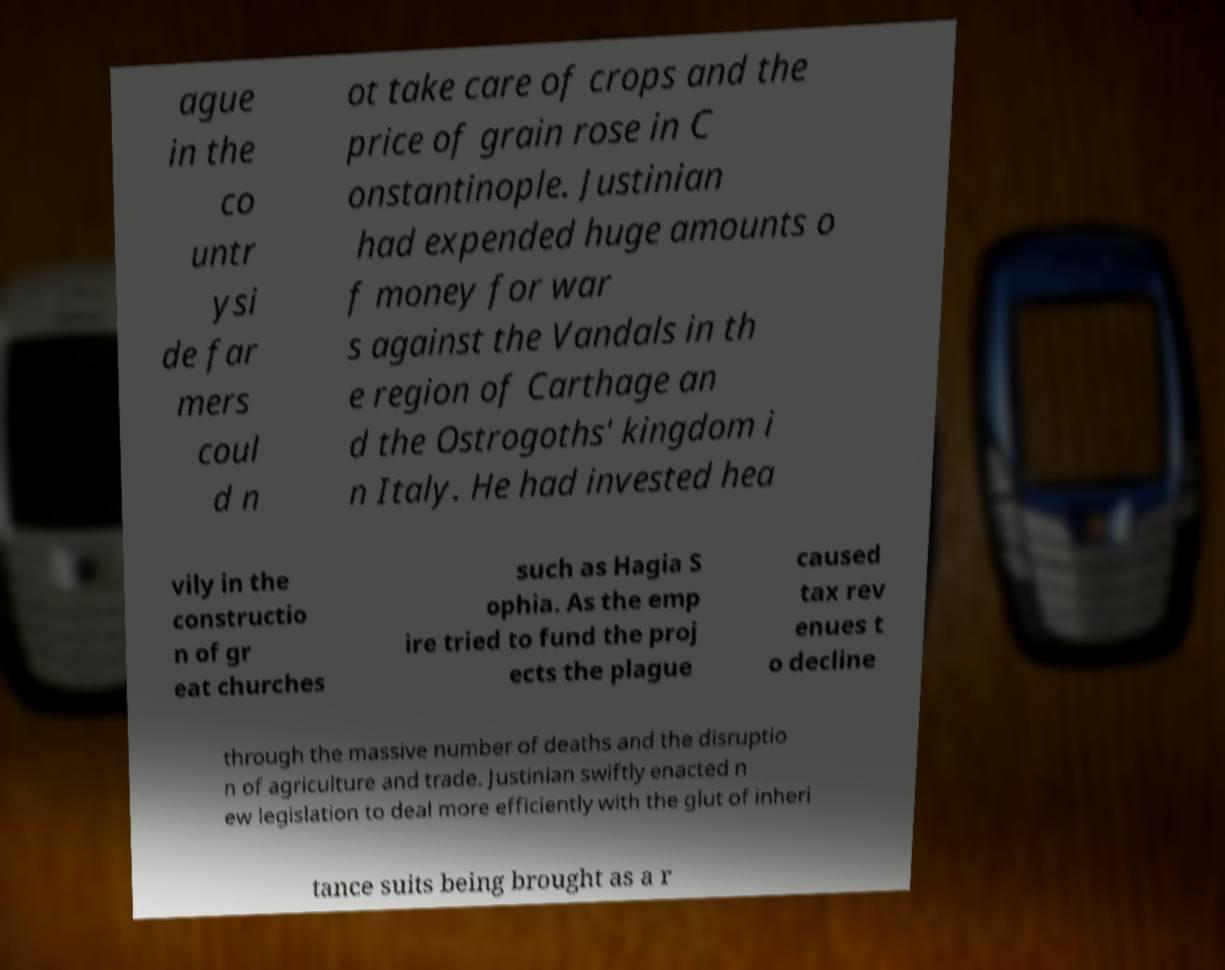Could you assist in decoding the text presented in this image and type it out clearly? ague in the co untr ysi de far mers coul d n ot take care of crops and the price of grain rose in C onstantinople. Justinian had expended huge amounts o f money for war s against the Vandals in th e region of Carthage an d the Ostrogoths' kingdom i n Italy. He had invested hea vily in the constructio n of gr eat churches such as Hagia S ophia. As the emp ire tried to fund the proj ects the plague caused tax rev enues t o decline through the massive number of deaths and the disruptio n of agriculture and trade. Justinian swiftly enacted n ew legislation to deal more efficiently with the glut of inheri tance suits being brought as a r 